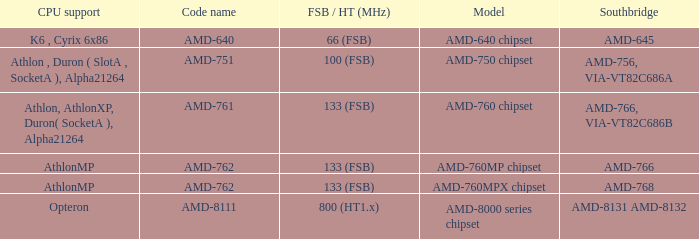What is the Southbridge when the CPU support was athlon, athlonxp, duron( socketa ), alpha21264? AMD-766, VIA-VT82C686B. 